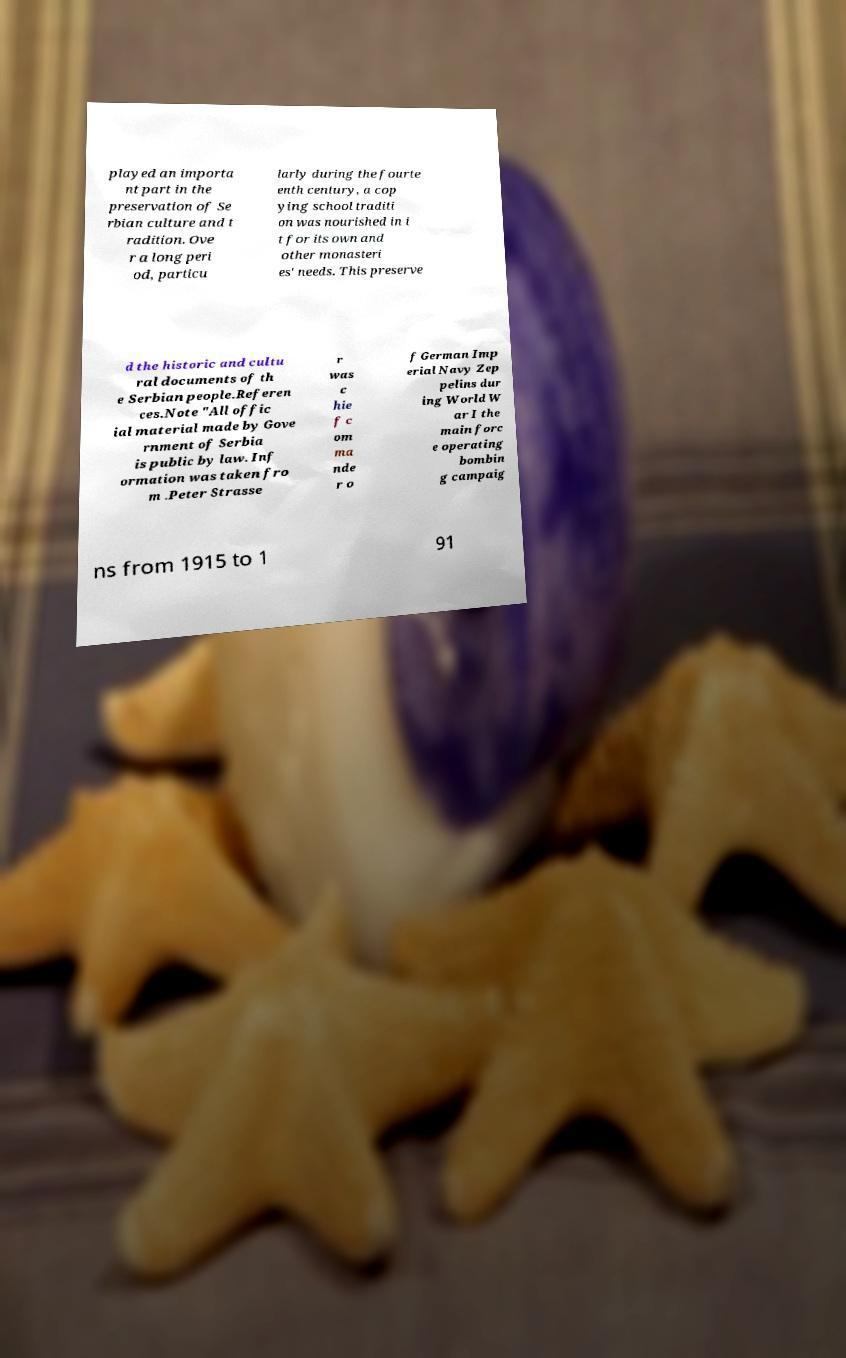For documentation purposes, I need the text within this image transcribed. Could you provide that? played an importa nt part in the preservation of Se rbian culture and t radition. Ove r a long peri od, particu larly during the fourte enth century, a cop ying school traditi on was nourished in i t for its own and other monasteri es' needs. This preserve d the historic and cultu ral documents of th e Serbian people.Referen ces.Note "All offic ial material made by Gove rnment of Serbia is public by law. Inf ormation was taken fro m .Peter Strasse r was c hie f c om ma nde r o f German Imp erial Navy Zep pelins dur ing World W ar I the main forc e operating bombin g campaig ns from 1915 to 1 91 